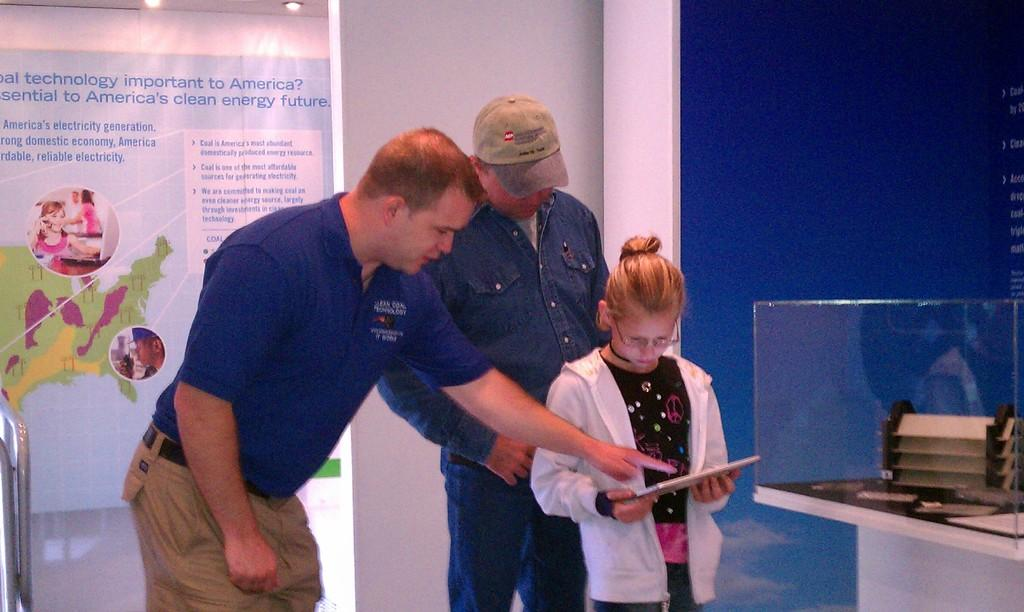<image>
Relay a brief, clear account of the picture shown. Three people looking at a tablet in front of a wall that has technology in blue letters. 